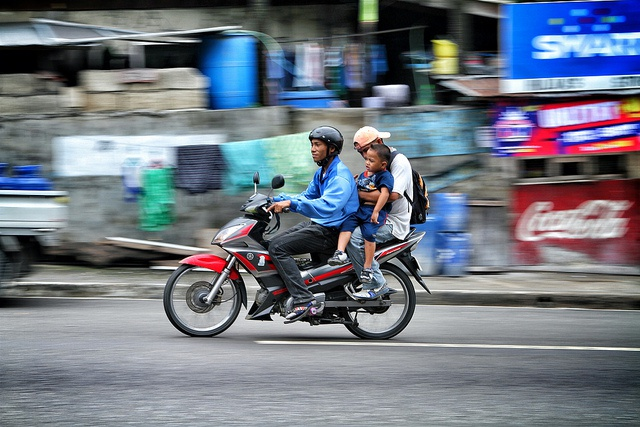Describe the objects in this image and their specific colors. I can see motorcycle in black, gray, darkgray, and lightgray tones, people in black, gray, and lightblue tones, people in black, white, gray, and darkgray tones, people in black, navy, salmon, and tan tones, and backpack in black, gray, and tan tones in this image. 